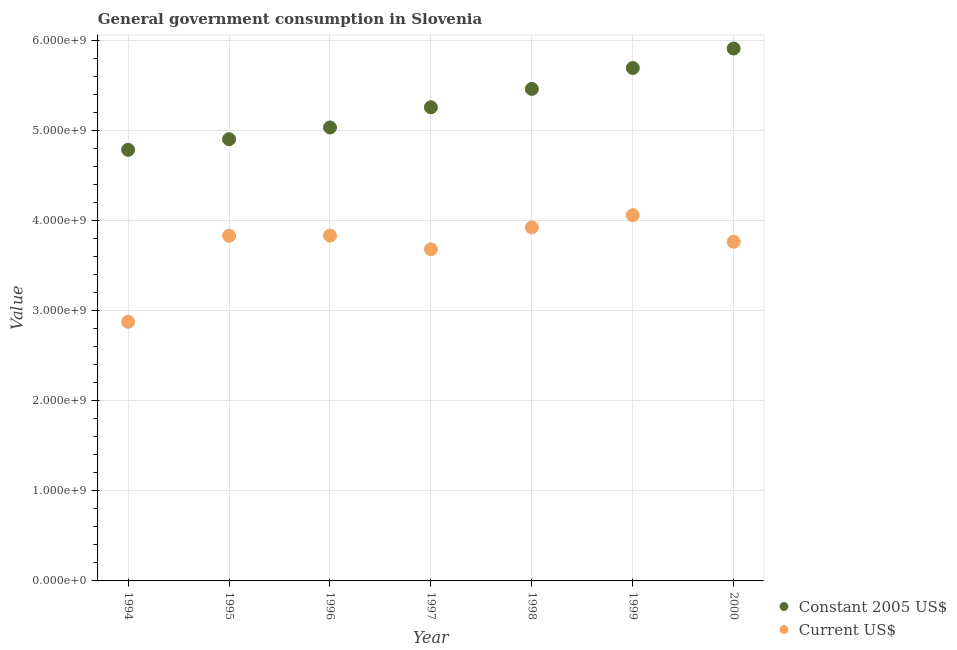Is the number of dotlines equal to the number of legend labels?
Your response must be concise. Yes. What is the value consumed in constant 2005 us$ in 1997?
Make the answer very short. 5.26e+09. Across all years, what is the maximum value consumed in current us$?
Your response must be concise. 4.06e+09. Across all years, what is the minimum value consumed in current us$?
Make the answer very short. 2.88e+09. In which year was the value consumed in constant 2005 us$ maximum?
Offer a very short reply. 2000. What is the total value consumed in constant 2005 us$ in the graph?
Provide a short and direct response. 3.70e+1. What is the difference between the value consumed in current us$ in 1996 and that in 2000?
Make the answer very short. 6.81e+07. What is the difference between the value consumed in current us$ in 2000 and the value consumed in constant 2005 us$ in 1996?
Provide a succinct answer. -1.27e+09. What is the average value consumed in current us$ per year?
Offer a terse response. 3.71e+09. In the year 2000, what is the difference between the value consumed in constant 2005 us$ and value consumed in current us$?
Your answer should be very brief. 2.14e+09. What is the ratio of the value consumed in current us$ in 1996 to that in 1998?
Your response must be concise. 0.98. Is the value consumed in current us$ in 1994 less than that in 1998?
Your response must be concise. Yes. Is the difference between the value consumed in current us$ in 1996 and 1999 greater than the difference between the value consumed in constant 2005 us$ in 1996 and 1999?
Your answer should be compact. Yes. What is the difference between the highest and the second highest value consumed in constant 2005 us$?
Your answer should be very brief. 2.16e+08. What is the difference between the highest and the lowest value consumed in current us$?
Provide a succinct answer. 1.18e+09. In how many years, is the value consumed in current us$ greater than the average value consumed in current us$ taken over all years?
Provide a succinct answer. 5. Is the value consumed in current us$ strictly greater than the value consumed in constant 2005 us$ over the years?
Provide a short and direct response. No. Is the value consumed in constant 2005 us$ strictly less than the value consumed in current us$ over the years?
Your answer should be very brief. No. How many years are there in the graph?
Make the answer very short. 7. What is the difference between two consecutive major ticks on the Y-axis?
Ensure brevity in your answer.  1.00e+09. Does the graph contain any zero values?
Your answer should be compact. No. How many legend labels are there?
Offer a terse response. 2. How are the legend labels stacked?
Give a very brief answer. Vertical. What is the title of the graph?
Your answer should be very brief. General government consumption in Slovenia. What is the label or title of the X-axis?
Your answer should be very brief. Year. What is the label or title of the Y-axis?
Offer a terse response. Value. What is the Value in Constant 2005 US$ in 1994?
Provide a succinct answer. 4.78e+09. What is the Value of Current US$ in 1994?
Make the answer very short. 2.88e+09. What is the Value of Constant 2005 US$ in 1995?
Give a very brief answer. 4.90e+09. What is the Value in Current US$ in 1995?
Your response must be concise. 3.83e+09. What is the Value in Constant 2005 US$ in 1996?
Keep it short and to the point. 5.03e+09. What is the Value in Current US$ in 1996?
Your answer should be compact. 3.83e+09. What is the Value in Constant 2005 US$ in 1997?
Offer a terse response. 5.26e+09. What is the Value in Current US$ in 1997?
Provide a succinct answer. 3.68e+09. What is the Value of Constant 2005 US$ in 1998?
Your answer should be compact. 5.46e+09. What is the Value of Current US$ in 1998?
Offer a terse response. 3.92e+09. What is the Value in Constant 2005 US$ in 1999?
Provide a succinct answer. 5.69e+09. What is the Value in Current US$ in 1999?
Offer a terse response. 4.06e+09. What is the Value in Constant 2005 US$ in 2000?
Ensure brevity in your answer.  5.91e+09. What is the Value in Current US$ in 2000?
Ensure brevity in your answer.  3.76e+09. Across all years, what is the maximum Value in Constant 2005 US$?
Provide a short and direct response. 5.91e+09. Across all years, what is the maximum Value in Current US$?
Give a very brief answer. 4.06e+09. Across all years, what is the minimum Value in Constant 2005 US$?
Offer a very short reply. 4.78e+09. Across all years, what is the minimum Value of Current US$?
Make the answer very short. 2.88e+09. What is the total Value in Constant 2005 US$ in the graph?
Give a very brief answer. 3.70e+1. What is the total Value in Current US$ in the graph?
Your answer should be very brief. 2.60e+1. What is the difference between the Value of Constant 2005 US$ in 1994 and that in 1995?
Your response must be concise. -1.17e+08. What is the difference between the Value of Current US$ in 1994 and that in 1995?
Your response must be concise. -9.55e+08. What is the difference between the Value in Constant 2005 US$ in 1994 and that in 1996?
Your answer should be very brief. -2.48e+08. What is the difference between the Value of Current US$ in 1994 and that in 1996?
Offer a very short reply. -9.56e+08. What is the difference between the Value of Constant 2005 US$ in 1994 and that in 1997?
Make the answer very short. -4.72e+08. What is the difference between the Value in Current US$ in 1994 and that in 1997?
Offer a terse response. -8.04e+08. What is the difference between the Value in Constant 2005 US$ in 1994 and that in 1998?
Your answer should be very brief. -6.75e+08. What is the difference between the Value in Current US$ in 1994 and that in 1998?
Your response must be concise. -1.05e+09. What is the difference between the Value in Constant 2005 US$ in 1994 and that in 1999?
Give a very brief answer. -9.08e+08. What is the difference between the Value of Current US$ in 1994 and that in 1999?
Your response must be concise. -1.18e+09. What is the difference between the Value of Constant 2005 US$ in 1994 and that in 2000?
Your answer should be compact. -1.12e+09. What is the difference between the Value in Current US$ in 1994 and that in 2000?
Offer a terse response. -8.88e+08. What is the difference between the Value in Constant 2005 US$ in 1995 and that in 1996?
Give a very brief answer. -1.30e+08. What is the difference between the Value of Current US$ in 1995 and that in 1996?
Provide a succinct answer. -1.36e+06. What is the difference between the Value of Constant 2005 US$ in 1995 and that in 1997?
Make the answer very short. -3.54e+08. What is the difference between the Value of Current US$ in 1995 and that in 1997?
Provide a short and direct response. 1.51e+08. What is the difference between the Value in Constant 2005 US$ in 1995 and that in 1998?
Give a very brief answer. -5.58e+08. What is the difference between the Value in Current US$ in 1995 and that in 1998?
Keep it short and to the point. -9.19e+07. What is the difference between the Value in Constant 2005 US$ in 1995 and that in 1999?
Keep it short and to the point. -7.90e+08. What is the difference between the Value in Current US$ in 1995 and that in 1999?
Offer a very short reply. -2.28e+08. What is the difference between the Value of Constant 2005 US$ in 1995 and that in 2000?
Make the answer very short. -1.01e+09. What is the difference between the Value in Current US$ in 1995 and that in 2000?
Offer a terse response. 6.67e+07. What is the difference between the Value in Constant 2005 US$ in 1996 and that in 1997?
Provide a succinct answer. -2.24e+08. What is the difference between the Value in Current US$ in 1996 and that in 1997?
Provide a succinct answer. 1.52e+08. What is the difference between the Value in Constant 2005 US$ in 1996 and that in 1998?
Your answer should be compact. -4.28e+08. What is the difference between the Value in Current US$ in 1996 and that in 1998?
Your response must be concise. -9.06e+07. What is the difference between the Value of Constant 2005 US$ in 1996 and that in 1999?
Give a very brief answer. -6.60e+08. What is the difference between the Value in Current US$ in 1996 and that in 1999?
Your answer should be very brief. -2.26e+08. What is the difference between the Value of Constant 2005 US$ in 1996 and that in 2000?
Keep it short and to the point. -8.76e+08. What is the difference between the Value in Current US$ in 1996 and that in 2000?
Provide a short and direct response. 6.81e+07. What is the difference between the Value in Constant 2005 US$ in 1997 and that in 1998?
Keep it short and to the point. -2.04e+08. What is the difference between the Value of Current US$ in 1997 and that in 1998?
Your answer should be very brief. -2.43e+08. What is the difference between the Value of Constant 2005 US$ in 1997 and that in 1999?
Keep it short and to the point. -4.36e+08. What is the difference between the Value in Current US$ in 1997 and that in 1999?
Keep it short and to the point. -3.78e+08. What is the difference between the Value in Constant 2005 US$ in 1997 and that in 2000?
Your answer should be compact. -6.52e+08. What is the difference between the Value of Current US$ in 1997 and that in 2000?
Keep it short and to the point. -8.40e+07. What is the difference between the Value in Constant 2005 US$ in 1998 and that in 1999?
Your answer should be compact. -2.32e+08. What is the difference between the Value of Current US$ in 1998 and that in 1999?
Give a very brief answer. -1.36e+08. What is the difference between the Value in Constant 2005 US$ in 1998 and that in 2000?
Offer a terse response. -4.48e+08. What is the difference between the Value of Current US$ in 1998 and that in 2000?
Ensure brevity in your answer.  1.59e+08. What is the difference between the Value of Constant 2005 US$ in 1999 and that in 2000?
Give a very brief answer. -2.16e+08. What is the difference between the Value in Current US$ in 1999 and that in 2000?
Ensure brevity in your answer.  2.94e+08. What is the difference between the Value in Constant 2005 US$ in 1994 and the Value in Current US$ in 1995?
Ensure brevity in your answer.  9.54e+08. What is the difference between the Value of Constant 2005 US$ in 1994 and the Value of Current US$ in 1996?
Offer a terse response. 9.52e+08. What is the difference between the Value in Constant 2005 US$ in 1994 and the Value in Current US$ in 1997?
Offer a terse response. 1.10e+09. What is the difference between the Value in Constant 2005 US$ in 1994 and the Value in Current US$ in 1998?
Give a very brief answer. 8.62e+08. What is the difference between the Value in Constant 2005 US$ in 1994 and the Value in Current US$ in 1999?
Provide a succinct answer. 7.26e+08. What is the difference between the Value in Constant 2005 US$ in 1994 and the Value in Current US$ in 2000?
Provide a short and direct response. 1.02e+09. What is the difference between the Value of Constant 2005 US$ in 1995 and the Value of Current US$ in 1996?
Your response must be concise. 1.07e+09. What is the difference between the Value of Constant 2005 US$ in 1995 and the Value of Current US$ in 1997?
Your answer should be very brief. 1.22e+09. What is the difference between the Value of Constant 2005 US$ in 1995 and the Value of Current US$ in 1998?
Provide a short and direct response. 9.79e+08. What is the difference between the Value of Constant 2005 US$ in 1995 and the Value of Current US$ in 1999?
Ensure brevity in your answer.  8.44e+08. What is the difference between the Value in Constant 2005 US$ in 1995 and the Value in Current US$ in 2000?
Give a very brief answer. 1.14e+09. What is the difference between the Value in Constant 2005 US$ in 1996 and the Value in Current US$ in 1997?
Ensure brevity in your answer.  1.35e+09. What is the difference between the Value of Constant 2005 US$ in 1996 and the Value of Current US$ in 1998?
Make the answer very short. 1.11e+09. What is the difference between the Value of Constant 2005 US$ in 1996 and the Value of Current US$ in 1999?
Keep it short and to the point. 9.74e+08. What is the difference between the Value in Constant 2005 US$ in 1996 and the Value in Current US$ in 2000?
Your answer should be compact. 1.27e+09. What is the difference between the Value of Constant 2005 US$ in 1997 and the Value of Current US$ in 1998?
Your answer should be compact. 1.33e+09. What is the difference between the Value of Constant 2005 US$ in 1997 and the Value of Current US$ in 1999?
Provide a short and direct response. 1.20e+09. What is the difference between the Value in Constant 2005 US$ in 1997 and the Value in Current US$ in 2000?
Your answer should be very brief. 1.49e+09. What is the difference between the Value in Constant 2005 US$ in 1998 and the Value in Current US$ in 1999?
Provide a succinct answer. 1.40e+09. What is the difference between the Value in Constant 2005 US$ in 1998 and the Value in Current US$ in 2000?
Give a very brief answer. 1.70e+09. What is the difference between the Value in Constant 2005 US$ in 1999 and the Value in Current US$ in 2000?
Provide a short and direct response. 1.93e+09. What is the average Value in Constant 2005 US$ per year?
Your response must be concise. 5.29e+09. What is the average Value of Current US$ per year?
Offer a terse response. 3.71e+09. In the year 1994, what is the difference between the Value in Constant 2005 US$ and Value in Current US$?
Offer a terse response. 1.91e+09. In the year 1995, what is the difference between the Value in Constant 2005 US$ and Value in Current US$?
Provide a short and direct response. 1.07e+09. In the year 1996, what is the difference between the Value in Constant 2005 US$ and Value in Current US$?
Provide a succinct answer. 1.20e+09. In the year 1997, what is the difference between the Value in Constant 2005 US$ and Value in Current US$?
Give a very brief answer. 1.58e+09. In the year 1998, what is the difference between the Value in Constant 2005 US$ and Value in Current US$?
Give a very brief answer. 1.54e+09. In the year 1999, what is the difference between the Value of Constant 2005 US$ and Value of Current US$?
Provide a short and direct response. 1.63e+09. In the year 2000, what is the difference between the Value of Constant 2005 US$ and Value of Current US$?
Ensure brevity in your answer.  2.14e+09. What is the ratio of the Value in Current US$ in 1994 to that in 1995?
Give a very brief answer. 0.75. What is the ratio of the Value in Constant 2005 US$ in 1994 to that in 1996?
Make the answer very short. 0.95. What is the ratio of the Value of Current US$ in 1994 to that in 1996?
Your response must be concise. 0.75. What is the ratio of the Value in Constant 2005 US$ in 1994 to that in 1997?
Your response must be concise. 0.91. What is the ratio of the Value in Current US$ in 1994 to that in 1997?
Your answer should be very brief. 0.78. What is the ratio of the Value in Constant 2005 US$ in 1994 to that in 1998?
Your answer should be compact. 0.88. What is the ratio of the Value in Current US$ in 1994 to that in 1998?
Your answer should be compact. 0.73. What is the ratio of the Value of Constant 2005 US$ in 1994 to that in 1999?
Provide a short and direct response. 0.84. What is the ratio of the Value of Current US$ in 1994 to that in 1999?
Offer a very short reply. 0.71. What is the ratio of the Value of Constant 2005 US$ in 1994 to that in 2000?
Provide a short and direct response. 0.81. What is the ratio of the Value in Current US$ in 1994 to that in 2000?
Provide a succinct answer. 0.76. What is the ratio of the Value in Constant 2005 US$ in 1995 to that in 1996?
Provide a succinct answer. 0.97. What is the ratio of the Value of Constant 2005 US$ in 1995 to that in 1997?
Provide a short and direct response. 0.93. What is the ratio of the Value of Current US$ in 1995 to that in 1997?
Keep it short and to the point. 1.04. What is the ratio of the Value of Constant 2005 US$ in 1995 to that in 1998?
Offer a terse response. 0.9. What is the ratio of the Value of Current US$ in 1995 to that in 1998?
Provide a succinct answer. 0.98. What is the ratio of the Value of Constant 2005 US$ in 1995 to that in 1999?
Your response must be concise. 0.86. What is the ratio of the Value of Current US$ in 1995 to that in 1999?
Ensure brevity in your answer.  0.94. What is the ratio of the Value in Constant 2005 US$ in 1995 to that in 2000?
Your answer should be very brief. 0.83. What is the ratio of the Value in Current US$ in 1995 to that in 2000?
Your response must be concise. 1.02. What is the ratio of the Value of Constant 2005 US$ in 1996 to that in 1997?
Provide a succinct answer. 0.96. What is the ratio of the Value of Current US$ in 1996 to that in 1997?
Ensure brevity in your answer.  1.04. What is the ratio of the Value of Constant 2005 US$ in 1996 to that in 1998?
Offer a very short reply. 0.92. What is the ratio of the Value of Current US$ in 1996 to that in 1998?
Make the answer very short. 0.98. What is the ratio of the Value of Constant 2005 US$ in 1996 to that in 1999?
Provide a succinct answer. 0.88. What is the ratio of the Value of Current US$ in 1996 to that in 1999?
Keep it short and to the point. 0.94. What is the ratio of the Value of Constant 2005 US$ in 1996 to that in 2000?
Make the answer very short. 0.85. What is the ratio of the Value of Current US$ in 1996 to that in 2000?
Provide a short and direct response. 1.02. What is the ratio of the Value in Constant 2005 US$ in 1997 to that in 1998?
Give a very brief answer. 0.96. What is the ratio of the Value in Current US$ in 1997 to that in 1998?
Provide a short and direct response. 0.94. What is the ratio of the Value of Constant 2005 US$ in 1997 to that in 1999?
Provide a succinct answer. 0.92. What is the ratio of the Value of Current US$ in 1997 to that in 1999?
Provide a short and direct response. 0.91. What is the ratio of the Value of Constant 2005 US$ in 1997 to that in 2000?
Provide a short and direct response. 0.89. What is the ratio of the Value of Current US$ in 1997 to that in 2000?
Ensure brevity in your answer.  0.98. What is the ratio of the Value in Constant 2005 US$ in 1998 to that in 1999?
Keep it short and to the point. 0.96. What is the ratio of the Value of Current US$ in 1998 to that in 1999?
Offer a terse response. 0.97. What is the ratio of the Value in Constant 2005 US$ in 1998 to that in 2000?
Keep it short and to the point. 0.92. What is the ratio of the Value in Current US$ in 1998 to that in 2000?
Your answer should be very brief. 1.04. What is the ratio of the Value in Constant 2005 US$ in 1999 to that in 2000?
Your response must be concise. 0.96. What is the ratio of the Value in Current US$ in 1999 to that in 2000?
Offer a very short reply. 1.08. What is the difference between the highest and the second highest Value in Constant 2005 US$?
Your answer should be compact. 2.16e+08. What is the difference between the highest and the second highest Value of Current US$?
Make the answer very short. 1.36e+08. What is the difference between the highest and the lowest Value of Constant 2005 US$?
Keep it short and to the point. 1.12e+09. What is the difference between the highest and the lowest Value in Current US$?
Your answer should be compact. 1.18e+09. 